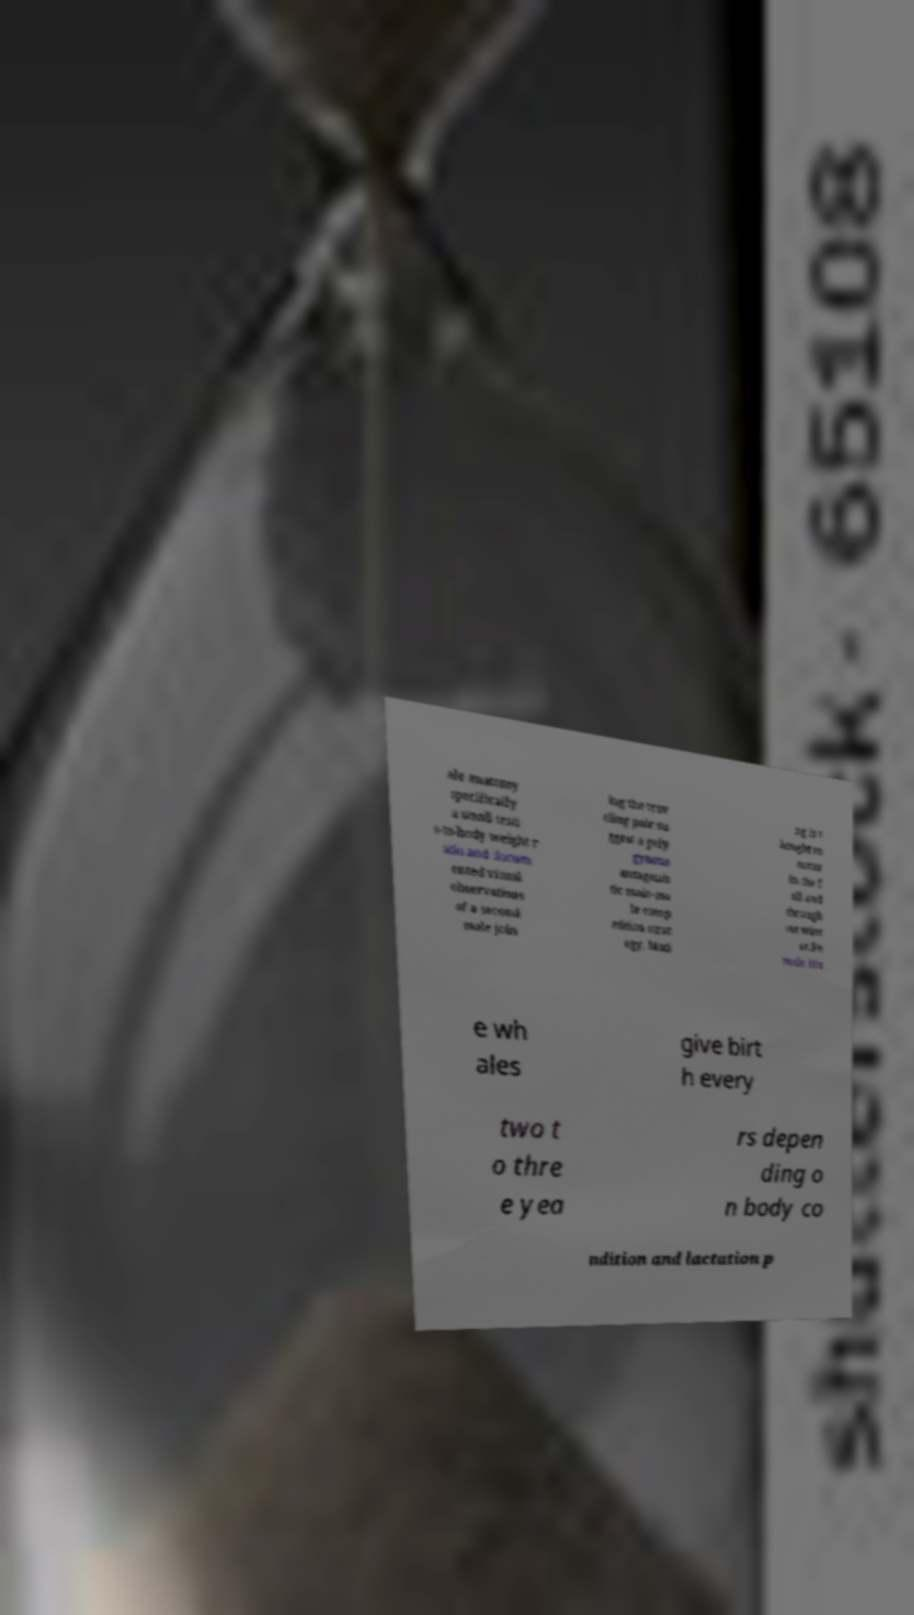Could you assist in decoding the text presented in this image and type it out clearly? ale anatomy specifically a small testi s-to-body weight r atio and docum ented visual observations of a second male join ing the trav eling pair su ggest a poly gynous antagonis tic male-ma le comp etition strat egy. Mati ng is t hought to occur in the f all and through out wint er.Fe male blu e wh ales give birt h every two t o thre e yea rs depen ding o n body co ndition and lactation p 